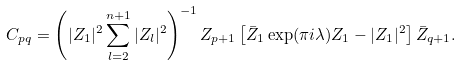Convert formula to latex. <formula><loc_0><loc_0><loc_500><loc_500>C _ { p q } = \left ( | Z _ { 1 } | ^ { 2 } \sum _ { l = 2 } ^ { n + 1 } | Z _ { l } | ^ { 2 } \right ) ^ { - 1 } Z _ { p + 1 } \left [ \bar { Z } _ { 1 } \exp ( \pi i \lambda ) Z _ { 1 } - | Z _ { 1 } | ^ { 2 } \right ] \bar { Z } _ { q + 1 } .</formula> 